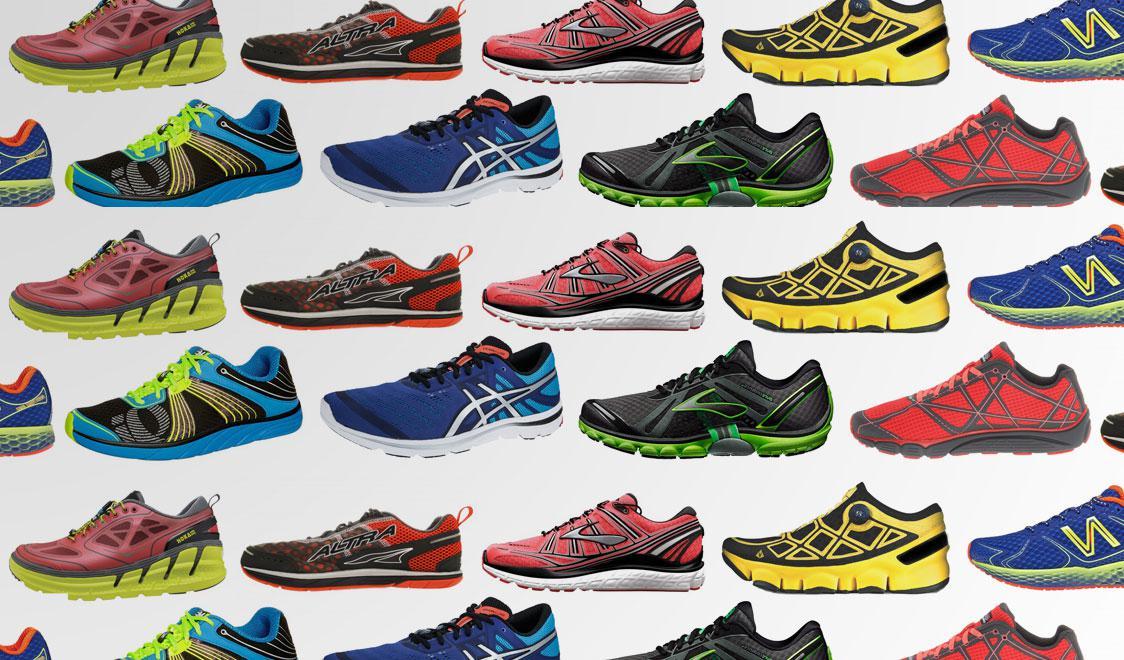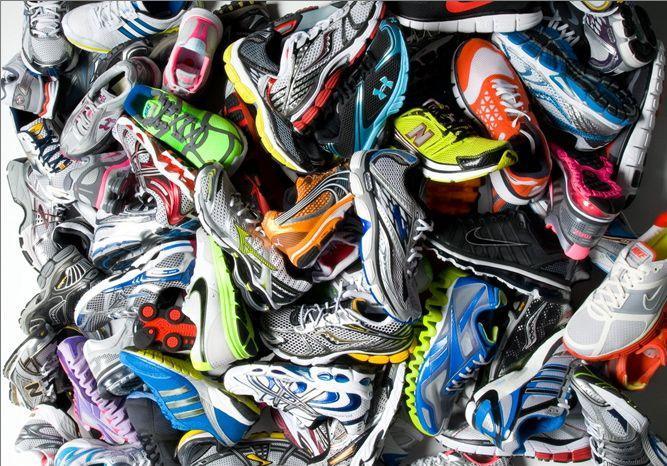The first image is the image on the left, the second image is the image on the right. Examine the images to the left and right. Is the description "the shoes are piled loosely in one of the images" accurate? Answer yes or no. Yes. 